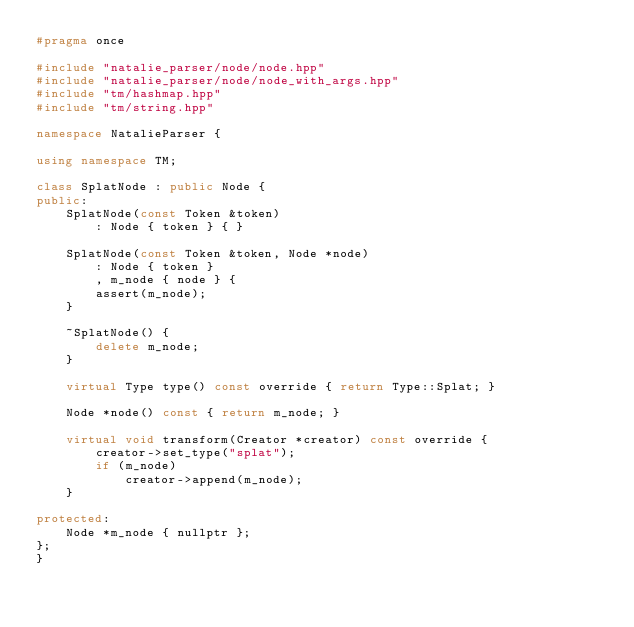<code> <loc_0><loc_0><loc_500><loc_500><_C++_>#pragma once

#include "natalie_parser/node/node.hpp"
#include "natalie_parser/node/node_with_args.hpp"
#include "tm/hashmap.hpp"
#include "tm/string.hpp"

namespace NatalieParser {

using namespace TM;

class SplatNode : public Node {
public:
    SplatNode(const Token &token)
        : Node { token } { }

    SplatNode(const Token &token, Node *node)
        : Node { token }
        , m_node { node } {
        assert(m_node);
    }

    ~SplatNode() {
        delete m_node;
    }

    virtual Type type() const override { return Type::Splat; }

    Node *node() const { return m_node; }

    virtual void transform(Creator *creator) const override {
        creator->set_type("splat");
        if (m_node)
            creator->append(m_node);
    }

protected:
    Node *m_node { nullptr };
};
}
</code> 